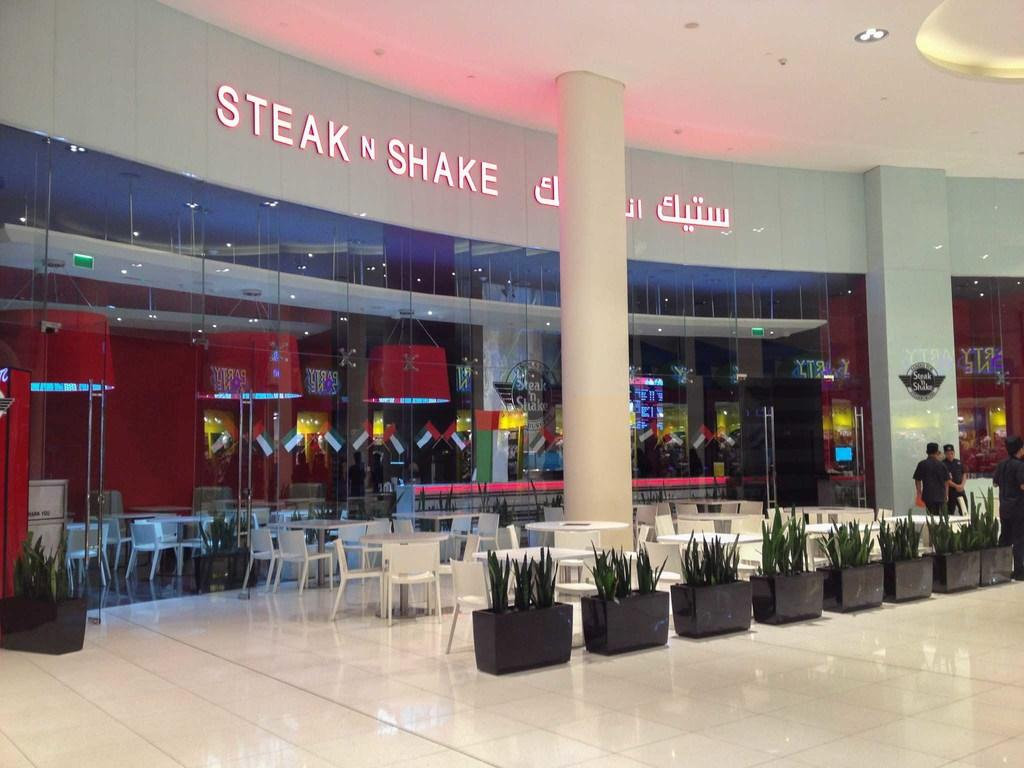Provide a one-sentence caption for the provided image. A Steak N Shake in a mall written in English and another language. 